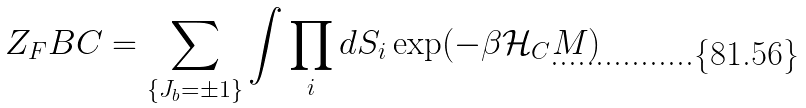<formula> <loc_0><loc_0><loc_500><loc_500>Z _ { F } B C = \sum _ { \{ J _ { b } = \pm 1 \} } \int \prod _ { i } d S _ { i } \exp ( - \beta \mathcal { H } _ { C } M )</formula> 